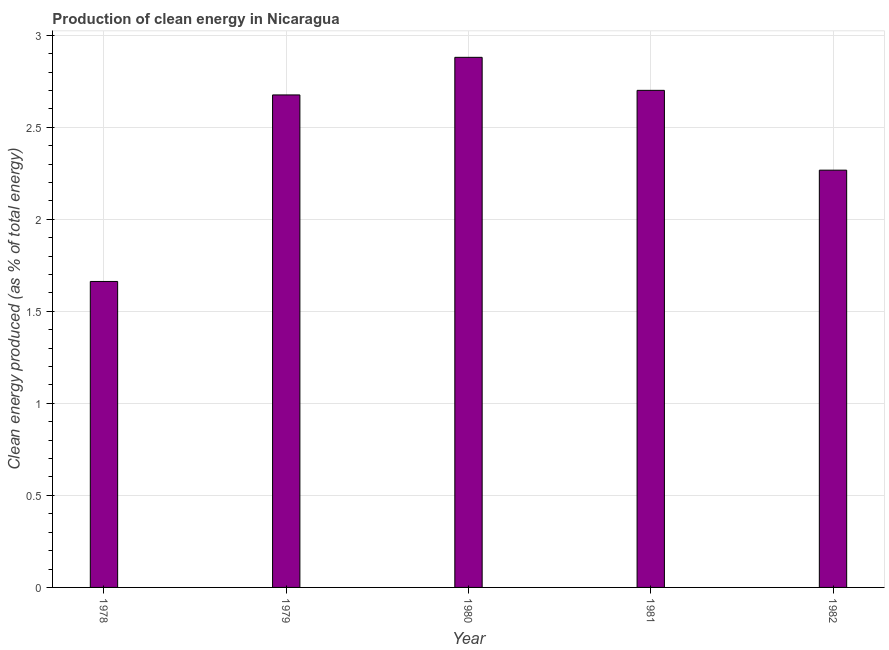Does the graph contain any zero values?
Offer a terse response. No. Does the graph contain grids?
Your answer should be very brief. Yes. What is the title of the graph?
Offer a very short reply. Production of clean energy in Nicaragua. What is the label or title of the Y-axis?
Provide a succinct answer. Clean energy produced (as % of total energy). What is the production of clean energy in 1979?
Make the answer very short. 2.68. Across all years, what is the maximum production of clean energy?
Offer a very short reply. 2.88. Across all years, what is the minimum production of clean energy?
Provide a succinct answer. 1.66. In which year was the production of clean energy minimum?
Ensure brevity in your answer.  1978. What is the sum of the production of clean energy?
Give a very brief answer. 12.19. What is the difference between the production of clean energy in 1978 and 1979?
Ensure brevity in your answer.  -1.01. What is the average production of clean energy per year?
Offer a terse response. 2.44. What is the median production of clean energy?
Give a very brief answer. 2.68. Do a majority of the years between 1979 and 1981 (inclusive) have production of clean energy greater than 1.9 %?
Provide a succinct answer. Yes. What is the ratio of the production of clean energy in 1980 to that in 1982?
Provide a succinct answer. 1.27. What is the difference between the highest and the second highest production of clean energy?
Give a very brief answer. 0.18. Is the sum of the production of clean energy in 1980 and 1981 greater than the maximum production of clean energy across all years?
Your answer should be compact. Yes. What is the difference between the highest and the lowest production of clean energy?
Your answer should be very brief. 1.22. In how many years, is the production of clean energy greater than the average production of clean energy taken over all years?
Give a very brief answer. 3. How many bars are there?
Offer a terse response. 5. Are all the bars in the graph horizontal?
Keep it short and to the point. No. How many years are there in the graph?
Ensure brevity in your answer.  5. What is the difference between two consecutive major ticks on the Y-axis?
Your response must be concise. 0.5. What is the Clean energy produced (as % of total energy) in 1978?
Give a very brief answer. 1.66. What is the Clean energy produced (as % of total energy) in 1979?
Provide a short and direct response. 2.68. What is the Clean energy produced (as % of total energy) of 1980?
Ensure brevity in your answer.  2.88. What is the Clean energy produced (as % of total energy) of 1981?
Offer a terse response. 2.7. What is the Clean energy produced (as % of total energy) of 1982?
Provide a short and direct response. 2.27. What is the difference between the Clean energy produced (as % of total energy) in 1978 and 1979?
Offer a terse response. -1.01. What is the difference between the Clean energy produced (as % of total energy) in 1978 and 1980?
Give a very brief answer. -1.22. What is the difference between the Clean energy produced (as % of total energy) in 1978 and 1981?
Offer a terse response. -1.04. What is the difference between the Clean energy produced (as % of total energy) in 1978 and 1982?
Offer a terse response. -0.6. What is the difference between the Clean energy produced (as % of total energy) in 1979 and 1980?
Your response must be concise. -0.2. What is the difference between the Clean energy produced (as % of total energy) in 1979 and 1981?
Provide a short and direct response. -0.02. What is the difference between the Clean energy produced (as % of total energy) in 1979 and 1982?
Keep it short and to the point. 0.41. What is the difference between the Clean energy produced (as % of total energy) in 1980 and 1981?
Give a very brief answer. 0.18. What is the difference between the Clean energy produced (as % of total energy) in 1980 and 1982?
Offer a very short reply. 0.61. What is the difference between the Clean energy produced (as % of total energy) in 1981 and 1982?
Provide a short and direct response. 0.43. What is the ratio of the Clean energy produced (as % of total energy) in 1978 to that in 1979?
Your answer should be very brief. 0.62. What is the ratio of the Clean energy produced (as % of total energy) in 1978 to that in 1980?
Ensure brevity in your answer.  0.58. What is the ratio of the Clean energy produced (as % of total energy) in 1978 to that in 1981?
Your answer should be very brief. 0.62. What is the ratio of the Clean energy produced (as % of total energy) in 1978 to that in 1982?
Give a very brief answer. 0.73. What is the ratio of the Clean energy produced (as % of total energy) in 1979 to that in 1980?
Make the answer very short. 0.93. What is the ratio of the Clean energy produced (as % of total energy) in 1979 to that in 1981?
Provide a short and direct response. 0.99. What is the ratio of the Clean energy produced (as % of total energy) in 1979 to that in 1982?
Provide a short and direct response. 1.18. What is the ratio of the Clean energy produced (as % of total energy) in 1980 to that in 1981?
Offer a terse response. 1.07. What is the ratio of the Clean energy produced (as % of total energy) in 1980 to that in 1982?
Offer a very short reply. 1.27. What is the ratio of the Clean energy produced (as % of total energy) in 1981 to that in 1982?
Offer a very short reply. 1.19. 